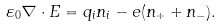<formula> <loc_0><loc_0><loc_500><loc_500>\varepsilon _ { 0 } \nabla \cdot E = q _ { i } n _ { i } - e ( n _ { + } + n _ { - } ) .</formula> 